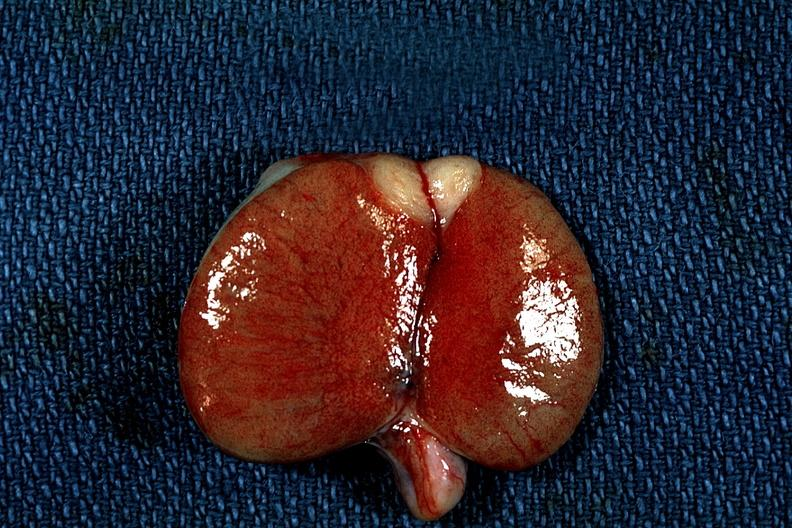what is present?
Answer the question using a single word or phrase. Testicle 